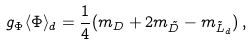<formula> <loc_0><loc_0><loc_500><loc_500>g _ { \Phi } \langle \Phi \rangle _ { d } = \frac { 1 } { 4 } ( m _ { D } + 2 m _ { \tilde { D } } - m _ { \tilde { L } _ { d } } ) \, ,</formula> 